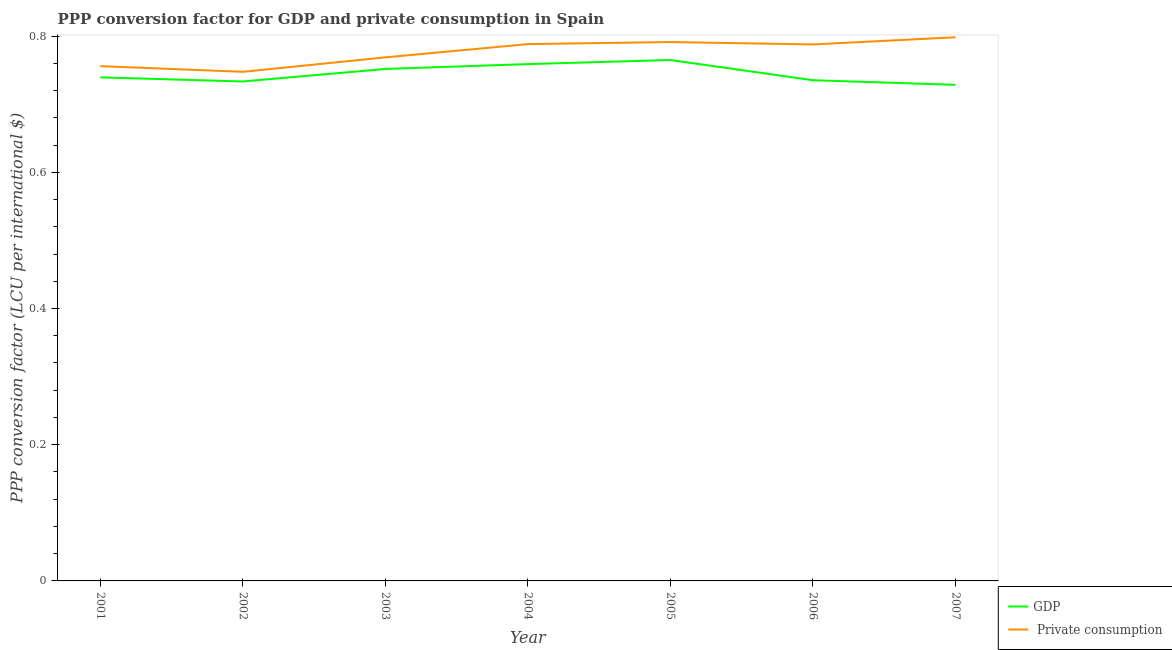How many different coloured lines are there?
Your response must be concise. 2. Is the number of lines equal to the number of legend labels?
Keep it short and to the point. Yes. What is the ppp conversion factor for gdp in 2003?
Your answer should be very brief. 0.75. Across all years, what is the maximum ppp conversion factor for gdp?
Offer a very short reply. 0.76. Across all years, what is the minimum ppp conversion factor for private consumption?
Make the answer very short. 0.75. In which year was the ppp conversion factor for private consumption maximum?
Offer a terse response. 2007. What is the total ppp conversion factor for private consumption in the graph?
Keep it short and to the point. 5.44. What is the difference between the ppp conversion factor for gdp in 2005 and that in 2007?
Make the answer very short. 0.04. What is the difference between the ppp conversion factor for gdp in 2003 and the ppp conversion factor for private consumption in 2005?
Keep it short and to the point. -0.04. What is the average ppp conversion factor for private consumption per year?
Your answer should be compact. 0.78. In the year 2001, what is the difference between the ppp conversion factor for gdp and ppp conversion factor for private consumption?
Provide a succinct answer. -0.02. What is the ratio of the ppp conversion factor for private consumption in 2002 to that in 2003?
Keep it short and to the point. 0.97. What is the difference between the highest and the second highest ppp conversion factor for gdp?
Provide a short and direct response. 0.01. What is the difference between the highest and the lowest ppp conversion factor for private consumption?
Give a very brief answer. 0.05. Is the ppp conversion factor for gdp strictly greater than the ppp conversion factor for private consumption over the years?
Provide a succinct answer. No. How many years are there in the graph?
Offer a terse response. 7. What is the difference between two consecutive major ticks on the Y-axis?
Keep it short and to the point. 0.2. Where does the legend appear in the graph?
Your answer should be very brief. Bottom right. How many legend labels are there?
Your answer should be very brief. 2. What is the title of the graph?
Keep it short and to the point. PPP conversion factor for GDP and private consumption in Spain. Does "Goods and services" appear as one of the legend labels in the graph?
Provide a succinct answer. No. What is the label or title of the Y-axis?
Keep it short and to the point. PPP conversion factor (LCU per international $). What is the PPP conversion factor (LCU per international $) of GDP in 2001?
Provide a short and direct response. 0.74. What is the PPP conversion factor (LCU per international $) in  Private consumption in 2001?
Give a very brief answer. 0.76. What is the PPP conversion factor (LCU per international $) of GDP in 2002?
Ensure brevity in your answer.  0.73. What is the PPP conversion factor (LCU per international $) of  Private consumption in 2002?
Your answer should be very brief. 0.75. What is the PPP conversion factor (LCU per international $) of GDP in 2003?
Give a very brief answer. 0.75. What is the PPP conversion factor (LCU per international $) in  Private consumption in 2003?
Provide a succinct answer. 0.77. What is the PPP conversion factor (LCU per international $) of GDP in 2004?
Ensure brevity in your answer.  0.76. What is the PPP conversion factor (LCU per international $) of  Private consumption in 2004?
Make the answer very short. 0.79. What is the PPP conversion factor (LCU per international $) in GDP in 2005?
Give a very brief answer. 0.76. What is the PPP conversion factor (LCU per international $) in  Private consumption in 2005?
Offer a very short reply. 0.79. What is the PPP conversion factor (LCU per international $) in GDP in 2006?
Your answer should be compact. 0.74. What is the PPP conversion factor (LCU per international $) in  Private consumption in 2006?
Your answer should be compact. 0.79. What is the PPP conversion factor (LCU per international $) of GDP in 2007?
Provide a short and direct response. 0.73. What is the PPP conversion factor (LCU per international $) of  Private consumption in 2007?
Give a very brief answer. 0.8. Across all years, what is the maximum PPP conversion factor (LCU per international $) in GDP?
Offer a very short reply. 0.76. Across all years, what is the maximum PPP conversion factor (LCU per international $) in  Private consumption?
Give a very brief answer. 0.8. Across all years, what is the minimum PPP conversion factor (LCU per international $) in GDP?
Make the answer very short. 0.73. Across all years, what is the minimum PPP conversion factor (LCU per international $) in  Private consumption?
Provide a succinct answer. 0.75. What is the total PPP conversion factor (LCU per international $) of GDP in the graph?
Provide a succinct answer. 5.21. What is the total PPP conversion factor (LCU per international $) of  Private consumption in the graph?
Your answer should be very brief. 5.44. What is the difference between the PPP conversion factor (LCU per international $) of GDP in 2001 and that in 2002?
Give a very brief answer. 0.01. What is the difference between the PPP conversion factor (LCU per international $) of  Private consumption in 2001 and that in 2002?
Make the answer very short. 0.01. What is the difference between the PPP conversion factor (LCU per international $) of GDP in 2001 and that in 2003?
Provide a succinct answer. -0.01. What is the difference between the PPP conversion factor (LCU per international $) in  Private consumption in 2001 and that in 2003?
Provide a short and direct response. -0.01. What is the difference between the PPP conversion factor (LCU per international $) in GDP in 2001 and that in 2004?
Offer a very short reply. -0.02. What is the difference between the PPP conversion factor (LCU per international $) of  Private consumption in 2001 and that in 2004?
Your answer should be compact. -0.03. What is the difference between the PPP conversion factor (LCU per international $) in GDP in 2001 and that in 2005?
Give a very brief answer. -0.03. What is the difference between the PPP conversion factor (LCU per international $) in  Private consumption in 2001 and that in 2005?
Provide a short and direct response. -0.04. What is the difference between the PPP conversion factor (LCU per international $) of GDP in 2001 and that in 2006?
Your answer should be very brief. 0. What is the difference between the PPP conversion factor (LCU per international $) in  Private consumption in 2001 and that in 2006?
Make the answer very short. -0.03. What is the difference between the PPP conversion factor (LCU per international $) of GDP in 2001 and that in 2007?
Ensure brevity in your answer.  0.01. What is the difference between the PPP conversion factor (LCU per international $) in  Private consumption in 2001 and that in 2007?
Offer a terse response. -0.04. What is the difference between the PPP conversion factor (LCU per international $) of GDP in 2002 and that in 2003?
Keep it short and to the point. -0.02. What is the difference between the PPP conversion factor (LCU per international $) of  Private consumption in 2002 and that in 2003?
Provide a short and direct response. -0.02. What is the difference between the PPP conversion factor (LCU per international $) in GDP in 2002 and that in 2004?
Keep it short and to the point. -0.03. What is the difference between the PPP conversion factor (LCU per international $) of  Private consumption in 2002 and that in 2004?
Make the answer very short. -0.04. What is the difference between the PPP conversion factor (LCU per international $) in GDP in 2002 and that in 2005?
Your answer should be very brief. -0.03. What is the difference between the PPP conversion factor (LCU per international $) in  Private consumption in 2002 and that in 2005?
Offer a very short reply. -0.04. What is the difference between the PPP conversion factor (LCU per international $) in GDP in 2002 and that in 2006?
Make the answer very short. -0. What is the difference between the PPP conversion factor (LCU per international $) of  Private consumption in 2002 and that in 2006?
Your answer should be compact. -0.04. What is the difference between the PPP conversion factor (LCU per international $) in GDP in 2002 and that in 2007?
Ensure brevity in your answer.  0.01. What is the difference between the PPP conversion factor (LCU per international $) in  Private consumption in 2002 and that in 2007?
Your answer should be very brief. -0.05. What is the difference between the PPP conversion factor (LCU per international $) of GDP in 2003 and that in 2004?
Your answer should be compact. -0.01. What is the difference between the PPP conversion factor (LCU per international $) in  Private consumption in 2003 and that in 2004?
Keep it short and to the point. -0.02. What is the difference between the PPP conversion factor (LCU per international $) of GDP in 2003 and that in 2005?
Keep it short and to the point. -0.01. What is the difference between the PPP conversion factor (LCU per international $) of  Private consumption in 2003 and that in 2005?
Offer a terse response. -0.02. What is the difference between the PPP conversion factor (LCU per international $) in GDP in 2003 and that in 2006?
Offer a very short reply. 0.02. What is the difference between the PPP conversion factor (LCU per international $) in  Private consumption in 2003 and that in 2006?
Make the answer very short. -0.02. What is the difference between the PPP conversion factor (LCU per international $) in GDP in 2003 and that in 2007?
Provide a succinct answer. 0.02. What is the difference between the PPP conversion factor (LCU per international $) in  Private consumption in 2003 and that in 2007?
Give a very brief answer. -0.03. What is the difference between the PPP conversion factor (LCU per international $) in GDP in 2004 and that in 2005?
Your response must be concise. -0.01. What is the difference between the PPP conversion factor (LCU per international $) in  Private consumption in 2004 and that in 2005?
Offer a very short reply. -0. What is the difference between the PPP conversion factor (LCU per international $) in GDP in 2004 and that in 2006?
Provide a succinct answer. 0.02. What is the difference between the PPP conversion factor (LCU per international $) in  Private consumption in 2004 and that in 2006?
Ensure brevity in your answer.  0. What is the difference between the PPP conversion factor (LCU per international $) in GDP in 2004 and that in 2007?
Provide a succinct answer. 0.03. What is the difference between the PPP conversion factor (LCU per international $) of  Private consumption in 2004 and that in 2007?
Provide a short and direct response. -0.01. What is the difference between the PPP conversion factor (LCU per international $) in GDP in 2005 and that in 2006?
Make the answer very short. 0.03. What is the difference between the PPP conversion factor (LCU per international $) of  Private consumption in 2005 and that in 2006?
Your answer should be very brief. 0. What is the difference between the PPP conversion factor (LCU per international $) in GDP in 2005 and that in 2007?
Make the answer very short. 0.04. What is the difference between the PPP conversion factor (LCU per international $) of  Private consumption in 2005 and that in 2007?
Your response must be concise. -0.01. What is the difference between the PPP conversion factor (LCU per international $) of GDP in 2006 and that in 2007?
Provide a succinct answer. 0.01. What is the difference between the PPP conversion factor (LCU per international $) in  Private consumption in 2006 and that in 2007?
Your answer should be compact. -0.01. What is the difference between the PPP conversion factor (LCU per international $) in GDP in 2001 and the PPP conversion factor (LCU per international $) in  Private consumption in 2002?
Ensure brevity in your answer.  -0.01. What is the difference between the PPP conversion factor (LCU per international $) of GDP in 2001 and the PPP conversion factor (LCU per international $) of  Private consumption in 2003?
Ensure brevity in your answer.  -0.03. What is the difference between the PPP conversion factor (LCU per international $) of GDP in 2001 and the PPP conversion factor (LCU per international $) of  Private consumption in 2004?
Make the answer very short. -0.05. What is the difference between the PPP conversion factor (LCU per international $) in GDP in 2001 and the PPP conversion factor (LCU per international $) in  Private consumption in 2005?
Keep it short and to the point. -0.05. What is the difference between the PPP conversion factor (LCU per international $) in GDP in 2001 and the PPP conversion factor (LCU per international $) in  Private consumption in 2006?
Offer a terse response. -0.05. What is the difference between the PPP conversion factor (LCU per international $) of GDP in 2001 and the PPP conversion factor (LCU per international $) of  Private consumption in 2007?
Provide a short and direct response. -0.06. What is the difference between the PPP conversion factor (LCU per international $) of GDP in 2002 and the PPP conversion factor (LCU per international $) of  Private consumption in 2003?
Offer a very short reply. -0.04. What is the difference between the PPP conversion factor (LCU per international $) of GDP in 2002 and the PPP conversion factor (LCU per international $) of  Private consumption in 2004?
Keep it short and to the point. -0.05. What is the difference between the PPP conversion factor (LCU per international $) of GDP in 2002 and the PPP conversion factor (LCU per international $) of  Private consumption in 2005?
Offer a terse response. -0.06. What is the difference between the PPP conversion factor (LCU per international $) of GDP in 2002 and the PPP conversion factor (LCU per international $) of  Private consumption in 2006?
Provide a short and direct response. -0.05. What is the difference between the PPP conversion factor (LCU per international $) in GDP in 2002 and the PPP conversion factor (LCU per international $) in  Private consumption in 2007?
Offer a terse response. -0.06. What is the difference between the PPP conversion factor (LCU per international $) of GDP in 2003 and the PPP conversion factor (LCU per international $) of  Private consumption in 2004?
Your answer should be very brief. -0.04. What is the difference between the PPP conversion factor (LCU per international $) of GDP in 2003 and the PPP conversion factor (LCU per international $) of  Private consumption in 2005?
Your answer should be compact. -0.04. What is the difference between the PPP conversion factor (LCU per international $) in GDP in 2003 and the PPP conversion factor (LCU per international $) in  Private consumption in 2006?
Provide a short and direct response. -0.04. What is the difference between the PPP conversion factor (LCU per international $) of GDP in 2003 and the PPP conversion factor (LCU per international $) of  Private consumption in 2007?
Your response must be concise. -0.05. What is the difference between the PPP conversion factor (LCU per international $) of GDP in 2004 and the PPP conversion factor (LCU per international $) of  Private consumption in 2005?
Give a very brief answer. -0.03. What is the difference between the PPP conversion factor (LCU per international $) in GDP in 2004 and the PPP conversion factor (LCU per international $) in  Private consumption in 2006?
Offer a very short reply. -0.03. What is the difference between the PPP conversion factor (LCU per international $) in GDP in 2004 and the PPP conversion factor (LCU per international $) in  Private consumption in 2007?
Make the answer very short. -0.04. What is the difference between the PPP conversion factor (LCU per international $) in GDP in 2005 and the PPP conversion factor (LCU per international $) in  Private consumption in 2006?
Keep it short and to the point. -0.02. What is the difference between the PPP conversion factor (LCU per international $) in GDP in 2005 and the PPP conversion factor (LCU per international $) in  Private consumption in 2007?
Make the answer very short. -0.03. What is the difference between the PPP conversion factor (LCU per international $) in GDP in 2006 and the PPP conversion factor (LCU per international $) in  Private consumption in 2007?
Make the answer very short. -0.06. What is the average PPP conversion factor (LCU per international $) of GDP per year?
Keep it short and to the point. 0.74. What is the average PPP conversion factor (LCU per international $) of  Private consumption per year?
Your answer should be very brief. 0.78. In the year 2001, what is the difference between the PPP conversion factor (LCU per international $) of GDP and PPP conversion factor (LCU per international $) of  Private consumption?
Provide a short and direct response. -0.02. In the year 2002, what is the difference between the PPP conversion factor (LCU per international $) in GDP and PPP conversion factor (LCU per international $) in  Private consumption?
Offer a terse response. -0.01. In the year 2003, what is the difference between the PPP conversion factor (LCU per international $) in GDP and PPP conversion factor (LCU per international $) in  Private consumption?
Ensure brevity in your answer.  -0.02. In the year 2004, what is the difference between the PPP conversion factor (LCU per international $) in GDP and PPP conversion factor (LCU per international $) in  Private consumption?
Keep it short and to the point. -0.03. In the year 2005, what is the difference between the PPP conversion factor (LCU per international $) in GDP and PPP conversion factor (LCU per international $) in  Private consumption?
Your response must be concise. -0.03. In the year 2006, what is the difference between the PPP conversion factor (LCU per international $) of GDP and PPP conversion factor (LCU per international $) of  Private consumption?
Ensure brevity in your answer.  -0.05. In the year 2007, what is the difference between the PPP conversion factor (LCU per international $) of GDP and PPP conversion factor (LCU per international $) of  Private consumption?
Give a very brief answer. -0.07. What is the ratio of the PPP conversion factor (LCU per international $) of GDP in 2001 to that in 2002?
Offer a very short reply. 1.01. What is the ratio of the PPP conversion factor (LCU per international $) in  Private consumption in 2001 to that in 2002?
Provide a short and direct response. 1.01. What is the ratio of the PPP conversion factor (LCU per international $) of GDP in 2001 to that in 2003?
Your answer should be very brief. 0.98. What is the ratio of the PPP conversion factor (LCU per international $) in  Private consumption in 2001 to that in 2003?
Provide a short and direct response. 0.98. What is the ratio of the PPP conversion factor (LCU per international $) of GDP in 2001 to that in 2004?
Your response must be concise. 0.97. What is the ratio of the PPP conversion factor (LCU per international $) of  Private consumption in 2001 to that in 2004?
Ensure brevity in your answer.  0.96. What is the ratio of the PPP conversion factor (LCU per international $) of GDP in 2001 to that in 2005?
Your answer should be compact. 0.97. What is the ratio of the PPP conversion factor (LCU per international $) in  Private consumption in 2001 to that in 2005?
Make the answer very short. 0.96. What is the ratio of the PPP conversion factor (LCU per international $) of  Private consumption in 2001 to that in 2006?
Your response must be concise. 0.96. What is the ratio of the PPP conversion factor (LCU per international $) in GDP in 2001 to that in 2007?
Ensure brevity in your answer.  1.02. What is the ratio of the PPP conversion factor (LCU per international $) in  Private consumption in 2001 to that in 2007?
Provide a succinct answer. 0.95. What is the ratio of the PPP conversion factor (LCU per international $) of GDP in 2002 to that in 2003?
Make the answer very short. 0.98. What is the ratio of the PPP conversion factor (LCU per international $) of  Private consumption in 2002 to that in 2003?
Keep it short and to the point. 0.97. What is the ratio of the PPP conversion factor (LCU per international $) of GDP in 2002 to that in 2004?
Your answer should be very brief. 0.97. What is the ratio of the PPP conversion factor (LCU per international $) of  Private consumption in 2002 to that in 2004?
Your answer should be compact. 0.95. What is the ratio of the PPP conversion factor (LCU per international $) in GDP in 2002 to that in 2005?
Provide a short and direct response. 0.96. What is the ratio of the PPP conversion factor (LCU per international $) in  Private consumption in 2002 to that in 2005?
Make the answer very short. 0.94. What is the ratio of the PPP conversion factor (LCU per international $) in  Private consumption in 2002 to that in 2006?
Your answer should be very brief. 0.95. What is the ratio of the PPP conversion factor (LCU per international $) in GDP in 2002 to that in 2007?
Provide a short and direct response. 1.01. What is the ratio of the PPP conversion factor (LCU per international $) of  Private consumption in 2002 to that in 2007?
Your response must be concise. 0.94. What is the ratio of the PPP conversion factor (LCU per international $) in GDP in 2003 to that in 2004?
Your answer should be very brief. 0.99. What is the ratio of the PPP conversion factor (LCU per international $) of  Private consumption in 2003 to that in 2004?
Provide a succinct answer. 0.98. What is the ratio of the PPP conversion factor (LCU per international $) in GDP in 2003 to that in 2005?
Your answer should be compact. 0.98. What is the ratio of the PPP conversion factor (LCU per international $) in  Private consumption in 2003 to that in 2005?
Keep it short and to the point. 0.97. What is the ratio of the PPP conversion factor (LCU per international $) in GDP in 2003 to that in 2006?
Your response must be concise. 1.02. What is the ratio of the PPP conversion factor (LCU per international $) of  Private consumption in 2003 to that in 2006?
Keep it short and to the point. 0.98. What is the ratio of the PPP conversion factor (LCU per international $) of GDP in 2003 to that in 2007?
Offer a very short reply. 1.03. What is the ratio of the PPP conversion factor (LCU per international $) in  Private consumption in 2004 to that in 2005?
Your answer should be very brief. 1. What is the ratio of the PPP conversion factor (LCU per international $) in GDP in 2004 to that in 2006?
Provide a succinct answer. 1.03. What is the ratio of the PPP conversion factor (LCU per international $) in GDP in 2004 to that in 2007?
Give a very brief answer. 1.04. What is the ratio of the PPP conversion factor (LCU per international $) of  Private consumption in 2004 to that in 2007?
Make the answer very short. 0.99. What is the ratio of the PPP conversion factor (LCU per international $) in GDP in 2005 to that in 2006?
Your answer should be compact. 1.04. What is the ratio of the PPP conversion factor (LCU per international $) of GDP in 2005 to that in 2007?
Your response must be concise. 1.05. What is the ratio of the PPP conversion factor (LCU per international $) in GDP in 2006 to that in 2007?
Ensure brevity in your answer.  1.01. What is the difference between the highest and the second highest PPP conversion factor (LCU per international $) in GDP?
Make the answer very short. 0.01. What is the difference between the highest and the second highest PPP conversion factor (LCU per international $) in  Private consumption?
Provide a short and direct response. 0.01. What is the difference between the highest and the lowest PPP conversion factor (LCU per international $) in GDP?
Make the answer very short. 0.04. What is the difference between the highest and the lowest PPP conversion factor (LCU per international $) in  Private consumption?
Keep it short and to the point. 0.05. 